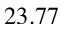<formula> <loc_0><loc_0><loc_500><loc_500>2 3 . 7 7</formula> 